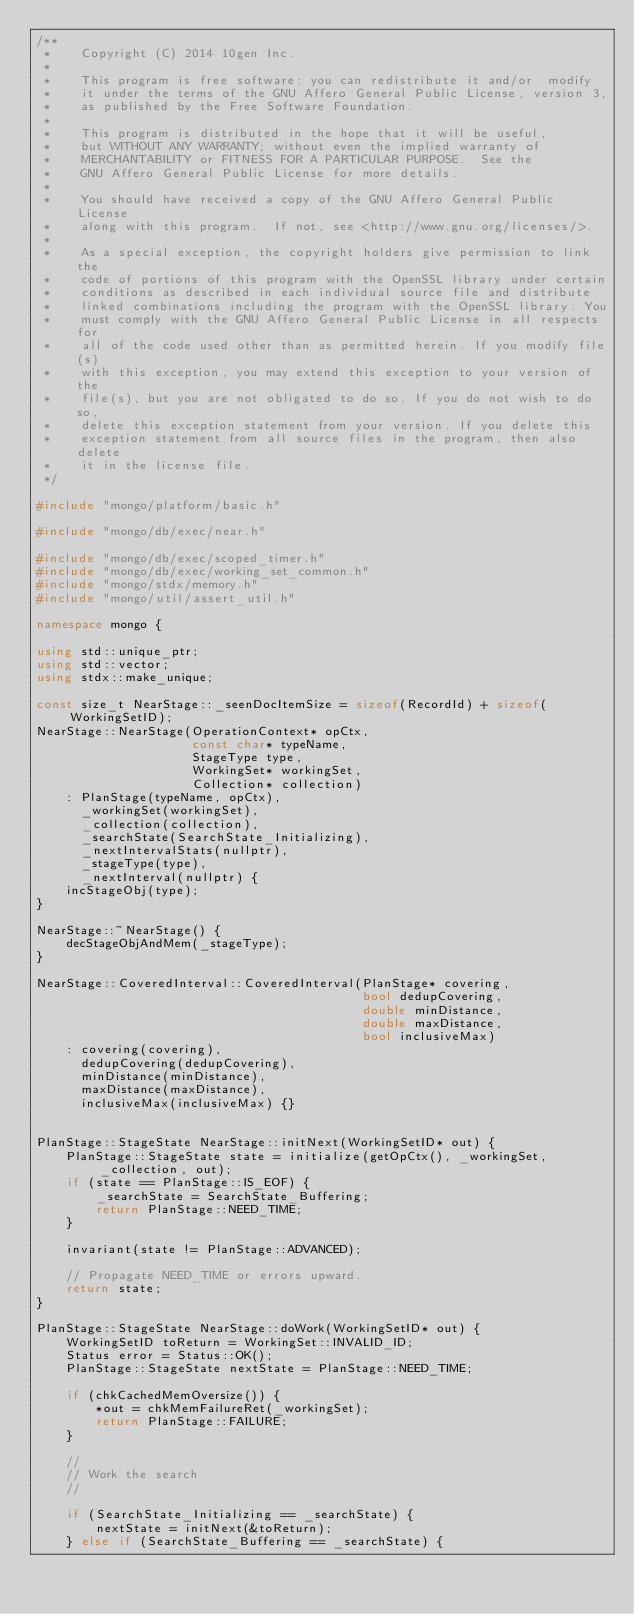Convert code to text. <code><loc_0><loc_0><loc_500><loc_500><_C++_>/**
 *    Copyright (C) 2014 10gen Inc.
 *
 *    This program is free software: you can redistribute it and/or  modify
 *    it under the terms of the GNU Affero General Public License, version 3,
 *    as published by the Free Software Foundation.
 *
 *    This program is distributed in the hope that it will be useful,
 *    but WITHOUT ANY WARRANTY; without even the implied warranty of
 *    MERCHANTABILITY or FITNESS FOR A PARTICULAR PURPOSE.  See the
 *    GNU Affero General Public License for more details.
 *
 *    You should have received a copy of the GNU Affero General Public License
 *    along with this program.  If not, see <http://www.gnu.org/licenses/>.
 *
 *    As a special exception, the copyright holders give permission to link the
 *    code of portions of this program with the OpenSSL library under certain
 *    conditions as described in each individual source file and distribute
 *    linked combinations including the program with the OpenSSL library. You
 *    must comply with the GNU Affero General Public License in all respects for
 *    all of the code used other than as permitted herein. If you modify file(s)
 *    with this exception, you may extend this exception to your version of the
 *    file(s), but you are not obligated to do so. If you do not wish to do so,
 *    delete this exception statement from your version. If you delete this
 *    exception statement from all source files in the program, then also delete
 *    it in the license file.
 */

#include "mongo/platform/basic.h"

#include "mongo/db/exec/near.h"

#include "mongo/db/exec/scoped_timer.h"
#include "mongo/db/exec/working_set_common.h"
#include "mongo/stdx/memory.h"
#include "mongo/util/assert_util.h"

namespace mongo {

using std::unique_ptr;
using std::vector;
using stdx::make_unique;

const size_t NearStage::_seenDocItemSize = sizeof(RecordId) + sizeof(WorkingSetID);
NearStage::NearStage(OperationContext* opCtx,
                     const char* typeName,
                     StageType type,
                     WorkingSet* workingSet,
                     Collection* collection)
    : PlanStage(typeName, opCtx),
      _workingSet(workingSet),
      _collection(collection),
      _searchState(SearchState_Initializing),
      _nextIntervalStats(nullptr),
      _stageType(type),
      _nextInterval(nullptr) {
    incStageObj(type);
}

NearStage::~NearStage() {
    decStageObjAndMem(_stageType);
}

NearStage::CoveredInterval::CoveredInterval(PlanStage* covering,
                                            bool dedupCovering,
                                            double minDistance,
                                            double maxDistance,
                                            bool inclusiveMax)
    : covering(covering),
      dedupCovering(dedupCovering),
      minDistance(minDistance),
      maxDistance(maxDistance),
      inclusiveMax(inclusiveMax) {}


PlanStage::StageState NearStage::initNext(WorkingSetID* out) {
    PlanStage::StageState state = initialize(getOpCtx(), _workingSet, _collection, out);
    if (state == PlanStage::IS_EOF) {
        _searchState = SearchState_Buffering;
        return PlanStage::NEED_TIME;
    }

    invariant(state != PlanStage::ADVANCED);

    // Propagate NEED_TIME or errors upward.
    return state;
}

PlanStage::StageState NearStage::doWork(WorkingSetID* out) {
    WorkingSetID toReturn = WorkingSet::INVALID_ID;
    Status error = Status::OK();
    PlanStage::StageState nextState = PlanStage::NEED_TIME;

    if (chkCachedMemOversize()) {
        *out = chkMemFailureRet(_workingSet);
        return PlanStage::FAILURE;
    }

    //
    // Work the search
    //

    if (SearchState_Initializing == _searchState) {
        nextState = initNext(&toReturn);
    } else if (SearchState_Buffering == _searchState) {</code> 